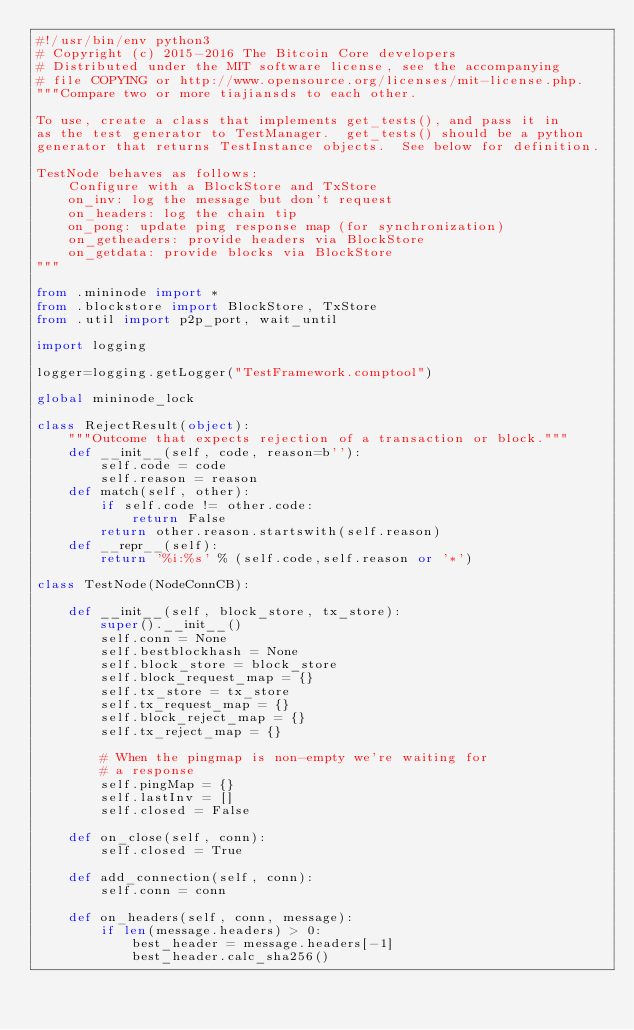Convert code to text. <code><loc_0><loc_0><loc_500><loc_500><_Python_>#!/usr/bin/env python3
# Copyright (c) 2015-2016 The Bitcoin Core developers
# Distributed under the MIT software license, see the accompanying
# file COPYING or http://www.opensource.org/licenses/mit-license.php.
"""Compare two or more tiajiansds to each other.

To use, create a class that implements get_tests(), and pass it in
as the test generator to TestManager.  get_tests() should be a python
generator that returns TestInstance objects.  See below for definition.

TestNode behaves as follows:
    Configure with a BlockStore and TxStore
    on_inv: log the message but don't request
    on_headers: log the chain tip
    on_pong: update ping response map (for synchronization)
    on_getheaders: provide headers via BlockStore
    on_getdata: provide blocks via BlockStore
"""

from .mininode import *
from .blockstore import BlockStore, TxStore
from .util import p2p_port, wait_until

import logging

logger=logging.getLogger("TestFramework.comptool")

global mininode_lock

class RejectResult(object):
    """Outcome that expects rejection of a transaction or block."""
    def __init__(self, code, reason=b''):
        self.code = code
        self.reason = reason
    def match(self, other):
        if self.code != other.code:
            return False
        return other.reason.startswith(self.reason)
    def __repr__(self):
        return '%i:%s' % (self.code,self.reason or '*')

class TestNode(NodeConnCB):

    def __init__(self, block_store, tx_store):
        super().__init__()
        self.conn = None
        self.bestblockhash = None
        self.block_store = block_store
        self.block_request_map = {}
        self.tx_store = tx_store
        self.tx_request_map = {}
        self.block_reject_map = {}
        self.tx_reject_map = {}

        # When the pingmap is non-empty we're waiting for 
        # a response
        self.pingMap = {} 
        self.lastInv = []
        self.closed = False

    def on_close(self, conn):
        self.closed = True

    def add_connection(self, conn):
        self.conn = conn

    def on_headers(self, conn, message):
        if len(message.headers) > 0:
            best_header = message.headers[-1]
            best_header.calc_sha256()</code> 